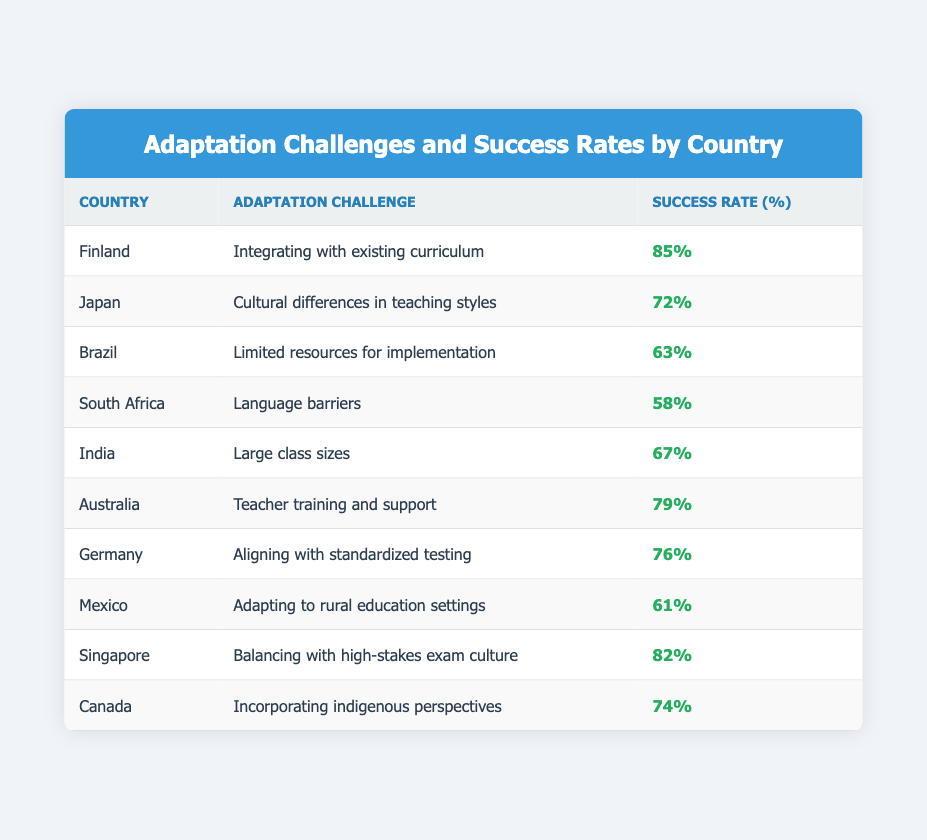What is the success rate for Finland? Finland has a success rate of 85% as indicated in the table.
Answer: 85% Which country has the lowest success rate? South Africa has the lowest success rate at 58%, according to the table.
Answer: 58% What is the average success rate of adaptation across all eight countries listed? To find the average, add the success rates: (85 + 72 + 63 + 58 + 67 + 79 + 76 + 61 + 82 + 74) =  85+72+63+58+67+79+76+61+82+74=  756; and then divide by the number of countries, which is 10. The average success rate is 756 / 10 = 75.6.
Answer: 75.6 Is it true that Japan's adaptation challenge is related to cultural differences in teaching styles? Yes, based on the information in the table, Japan's adaptation challenge is indeed associated with cultural differences in teaching styles.
Answer: Yes Which country faces challenges in incorporating indigenous perspectives? Canada faces challenges in incorporating indigenous perspectives, as stated in the table.
Answer: Canada If you compare Finland and Australia, which country has a higher success rate and by how much? Finland has a higher success rate at 85% compared to Australia's 79%. The difference is 85 - 79 = 6%.
Answer: 6% Are language barriers the adaptation challenge faced by South Africa? Yes, the table indicates that South Africa's adaptation challenge is related to language barriers.
Answer: Yes How many countries have a success rate of 70% or higher? The countries with a success rate of 70% or higher are Finland (85), Japan (72), Australia (79), Germany (76), Singapore (82), and Canada (74). This totals to 6 countries.
Answer: 6 